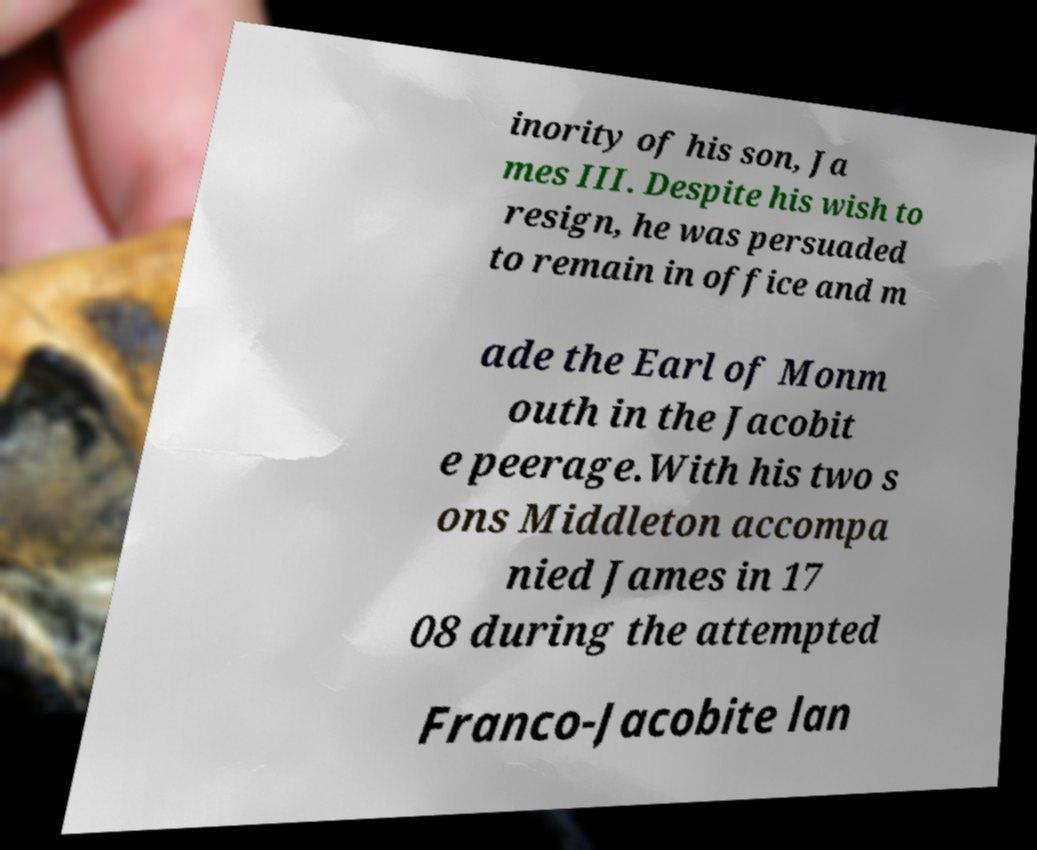Could you assist in decoding the text presented in this image and type it out clearly? inority of his son, Ja mes III. Despite his wish to resign, he was persuaded to remain in office and m ade the Earl of Monm outh in the Jacobit e peerage.With his two s ons Middleton accompa nied James in 17 08 during the attempted Franco-Jacobite lan 